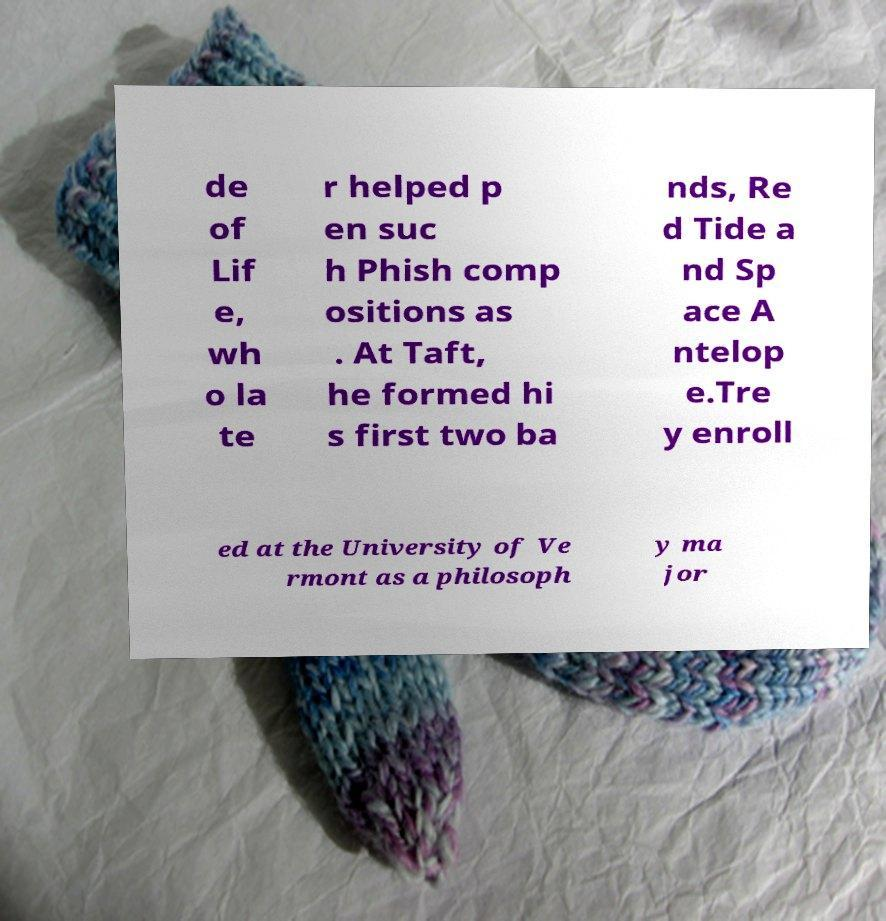Could you extract and type out the text from this image? de of Lif e, wh o la te r helped p en suc h Phish comp ositions as . At Taft, he formed hi s first two ba nds, Re d Tide a nd Sp ace A ntelop e.Tre y enroll ed at the University of Ve rmont as a philosoph y ma jor 